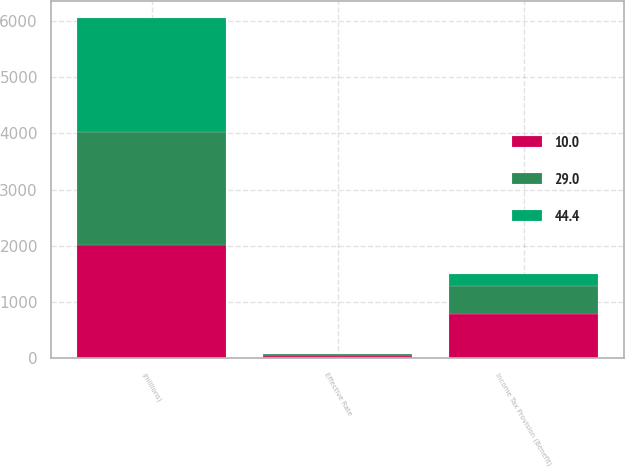<chart> <loc_0><loc_0><loc_500><loc_500><stacked_bar_chart><ecel><fcel>(millions)<fcel>Income Tax Provision (Benefit)<fcel>Effective Rate<nl><fcel>10<fcel>2016<fcel>787<fcel>44.4<nl><fcel>44.4<fcel>2015<fcel>222<fcel>10<nl><fcel>29<fcel>2014<fcel>496<fcel>29<nl></chart> 